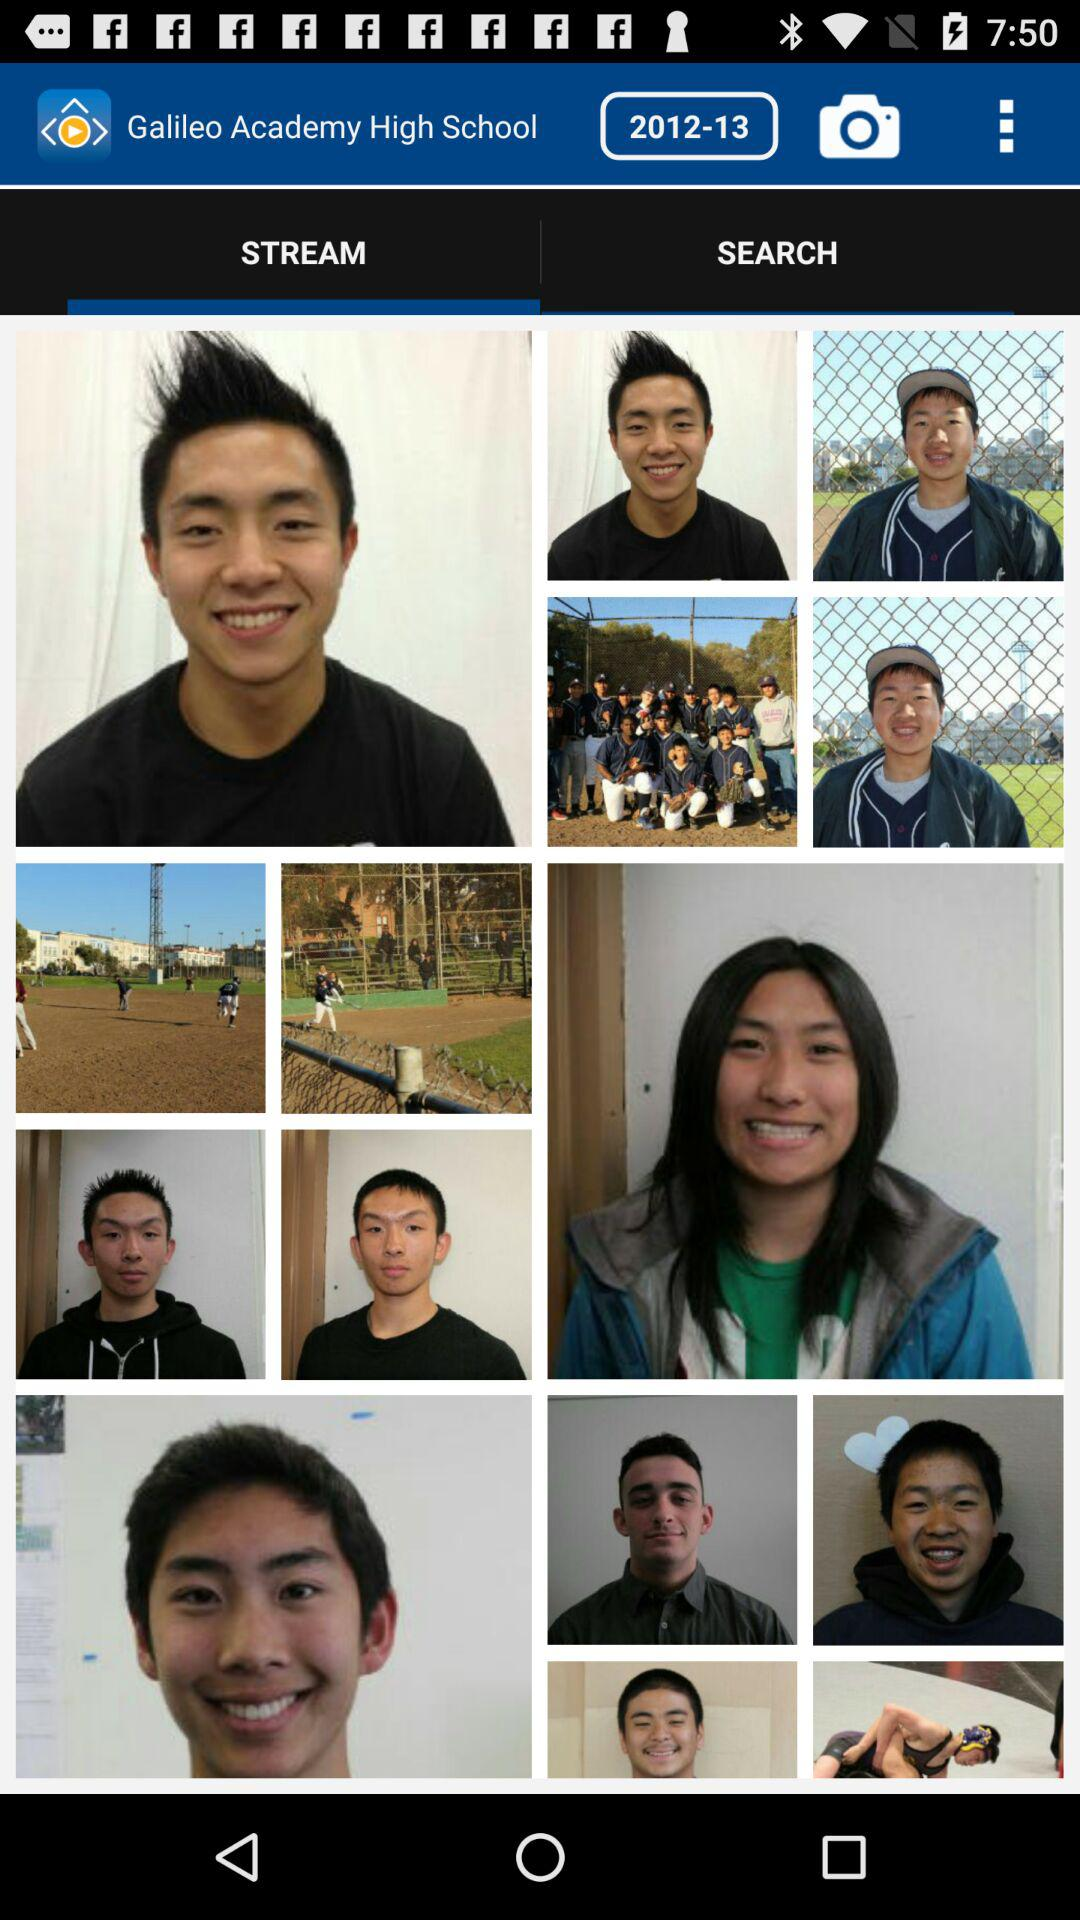Which tab is selected? The selected tab is "STREAM". 